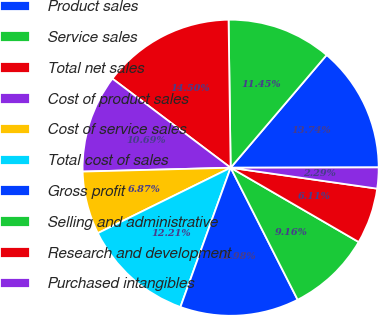<chart> <loc_0><loc_0><loc_500><loc_500><pie_chart><fcel>Product sales<fcel>Service sales<fcel>Total net sales<fcel>Cost of product sales<fcel>Cost of service sales<fcel>Total cost of sales<fcel>Gross profit<fcel>Selling and administrative<fcel>Research and development<fcel>Purchased intangibles<nl><fcel>13.74%<fcel>11.45%<fcel>14.5%<fcel>10.69%<fcel>6.87%<fcel>12.21%<fcel>12.98%<fcel>9.16%<fcel>6.11%<fcel>2.29%<nl></chart> 